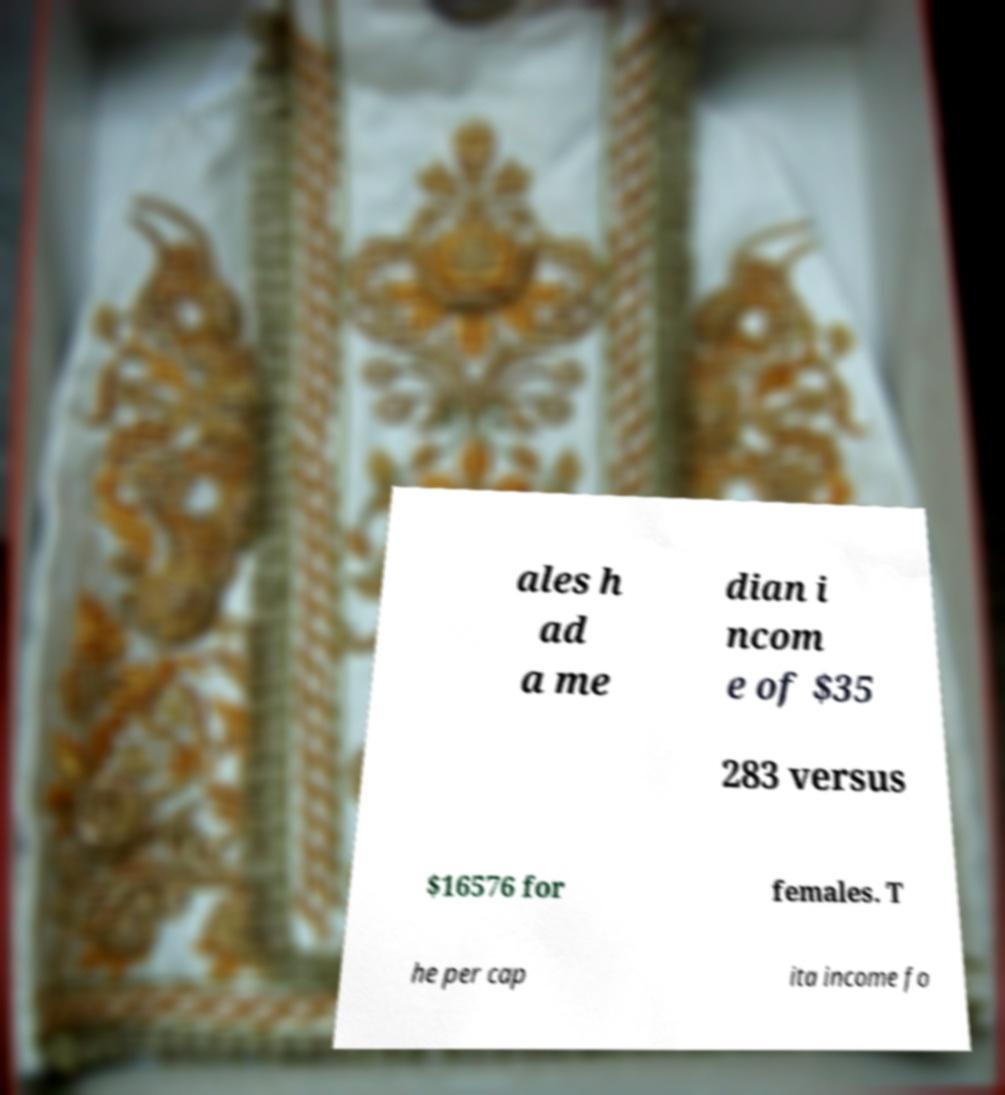Please read and relay the text visible in this image. What does it say? ales h ad a me dian i ncom e of $35 283 versus $16576 for females. T he per cap ita income fo 